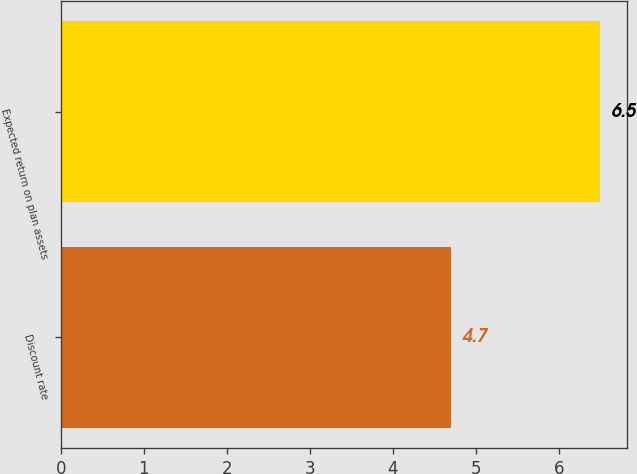Convert chart to OTSL. <chart><loc_0><loc_0><loc_500><loc_500><bar_chart><fcel>Discount rate<fcel>Expected return on plan assets<nl><fcel>4.7<fcel>6.5<nl></chart> 